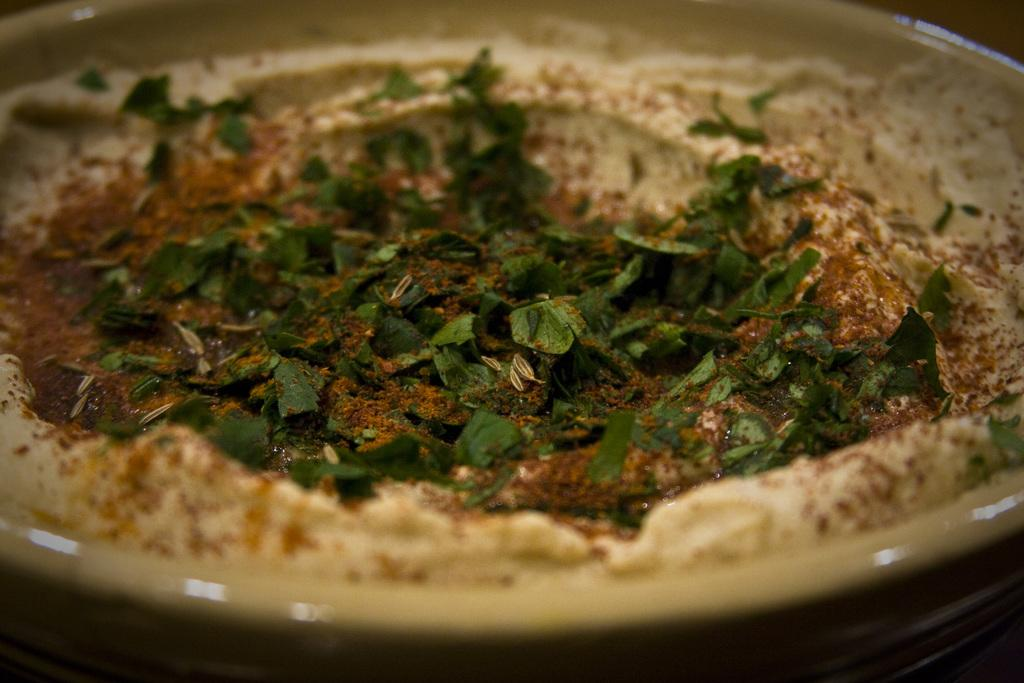What is present in the image? There is a bowl in the image. What is inside the bowl? The bowl contains a food item. What type of food item is in the bowl? The food item consists of leaves. What rule is being enforced in the image? There is no rule being enforced in the image; it simply shows a bowl with a food item made of leaves. 